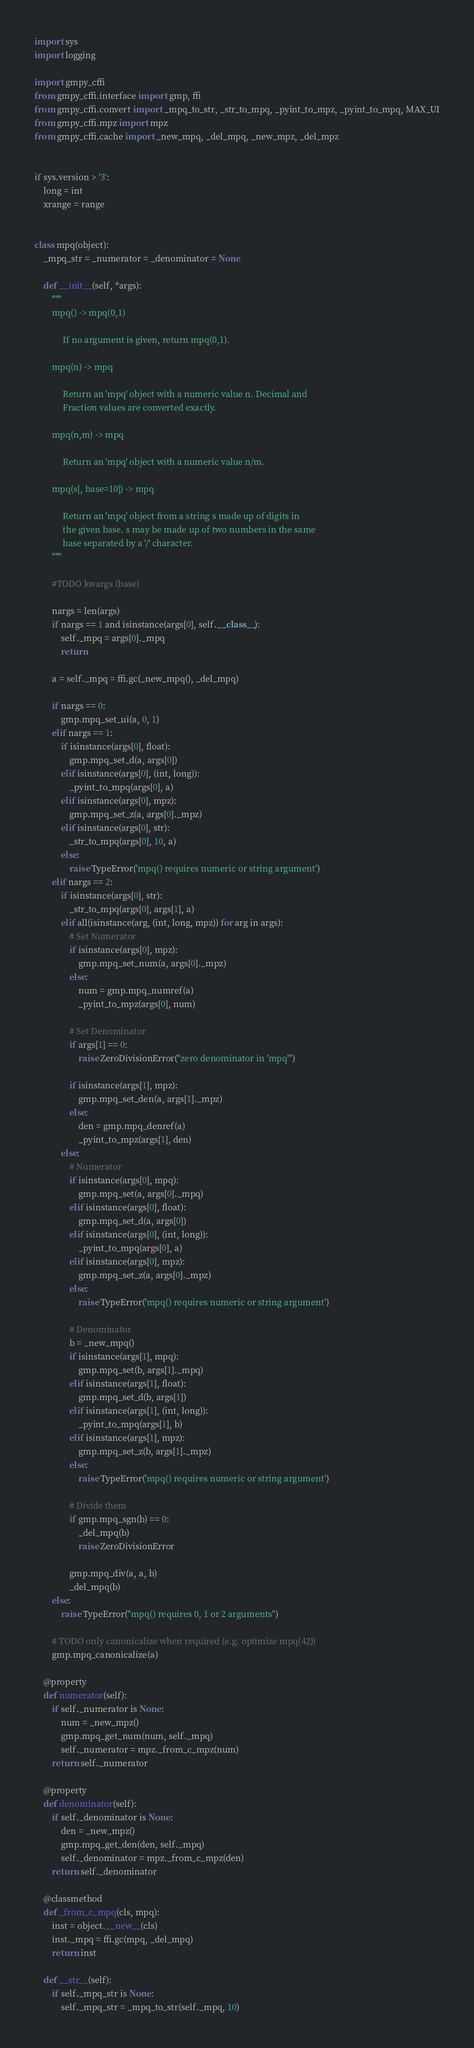<code> <loc_0><loc_0><loc_500><loc_500><_Python_>import sys
import logging

import gmpy_cffi
from gmpy_cffi.interface import gmp, ffi
from gmpy_cffi.convert import _mpq_to_str, _str_to_mpq, _pyint_to_mpz, _pyint_to_mpq, MAX_UI
from gmpy_cffi.mpz import mpz
from gmpy_cffi.cache import _new_mpq, _del_mpq, _new_mpz, _del_mpz


if sys.version > '3':
    long = int
    xrange = range


class mpq(object):
    _mpq_str = _numerator = _denominator = None

    def __init__(self, *args):
        """
        mpq() -> mpq(0,1)

             If no argument is given, return mpq(0,1).

        mpq(n) -> mpq

             Return an 'mpq' object with a numeric value n. Decimal and
             Fraction values are converted exactly.

        mpq(n,m) -> mpq

             Return an 'mpq' object with a numeric value n/m.

        mpq(s[, base=10]) -> mpq

             Return an 'mpq' object from a string s made up of digits in
             the given base. s may be made up of two numbers in the same
             base separated by a '/' character.
        """

        #TODO kwargs (base)

        nargs = len(args)
        if nargs == 1 and isinstance(args[0], self.__class__):
            self._mpq = args[0]._mpq
            return

        a = self._mpq = ffi.gc(_new_mpq(), _del_mpq)

        if nargs == 0:
            gmp.mpq_set_ui(a, 0, 1)
        elif nargs == 1:
            if isinstance(args[0], float):
                gmp.mpq_set_d(a, args[0])
            elif isinstance(args[0], (int, long)):
                _pyint_to_mpq(args[0], a)
            elif isinstance(args[0], mpz):
                gmp.mpq_set_z(a, args[0]._mpz)
            elif isinstance(args[0], str):
                _str_to_mpq(args[0], 10, a)
            else:
                raise TypeError('mpq() requires numeric or string argument')
        elif nargs == 2:
            if isinstance(args[0], str):
                _str_to_mpq(args[0], args[1], a)
            elif all(isinstance(arg, (int, long, mpz)) for arg in args):
                # Set Numerator
                if isinstance(args[0], mpz):
                    gmp.mpq_set_num(a, args[0]._mpz)
                else:
                    num = gmp.mpq_numref(a)
                    _pyint_to_mpz(args[0], num)

                # Set Denominator
                if args[1] == 0:
                    raise ZeroDivisionError("zero denominator in 'mpq'")

                if isinstance(args[1], mpz):
                    gmp.mpq_set_den(a, args[1]._mpz)
                else:
                    den = gmp.mpq_denref(a)
                    _pyint_to_mpz(args[1], den)
            else:
                # Numerator
                if isinstance(args[0], mpq):
                    gmp.mpq_set(a, args[0]._mpq)
                elif isinstance(args[0], float):
                    gmp.mpq_set_d(a, args[0])
                elif isinstance(args[0], (int, long)):
                    _pyint_to_mpq(args[0], a)
                elif isinstance(args[0], mpz):
                    gmp.mpq_set_z(a, args[0]._mpz)
                else:
                    raise TypeError('mpq() requires numeric or string argument')

                # Denominator
                b = _new_mpq()
                if isinstance(args[1], mpq):
                    gmp.mpq_set(b, args[1]._mpq)
                elif isinstance(args[1], float):
                    gmp.mpq_set_d(b, args[1])
                elif isinstance(args[1], (int, long)):
                    _pyint_to_mpq(args[1], b)
                elif isinstance(args[1], mpz):
                    gmp.mpq_set_z(b, args[1]._mpz)
                else:
                    raise TypeError('mpq() requires numeric or string argument')

                # Divide them
                if gmp.mpq_sgn(b) == 0:
                    _del_mpq(b)
                    raise ZeroDivisionError

                gmp.mpq_div(a, a, b)
                _del_mpq(b)
        else:
            raise TypeError("mpq() requires 0, 1 or 2 arguments")

        # TODO only canonicalize when required (e.g. optimize mpq(42))
        gmp.mpq_canonicalize(a)

    @property
    def numerator(self):
        if self._numerator is None:
            num = _new_mpz()
            gmp.mpq_get_num(num, self._mpq)
            self._numerator = mpz._from_c_mpz(num)
        return self._numerator

    @property
    def denominator(self):
        if self._denominator is None:
            den = _new_mpz()
            gmp.mpq_get_den(den, self._mpq)
            self._denominator = mpz._from_c_mpz(den)
        return self._denominator

    @classmethod
    def _from_c_mpq(cls, mpq):
        inst = object.__new__(cls)
        inst._mpq = ffi.gc(mpq, _del_mpq)
        return inst

    def __str__(self):
        if self._mpq_str is None:
            self._mpq_str = _mpq_to_str(self._mpq, 10)</code> 